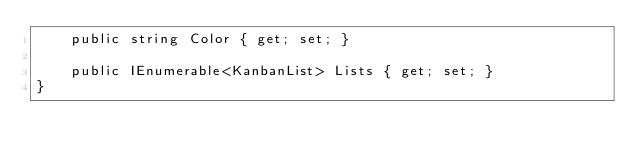Convert code to text. <code><loc_0><loc_0><loc_500><loc_500><_C#_>    public string Color { get; set; }

    public IEnumerable<KanbanList> Lists { get; set; }
}</code> 